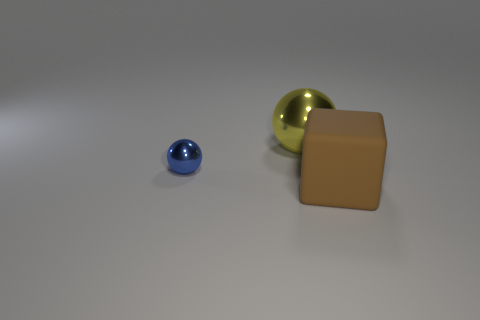Add 3 yellow spheres. How many objects exist? 6 Add 1 big brown matte things. How many big brown matte things exist? 2 Subtract 1 yellow balls. How many objects are left? 2 Subtract all spheres. How many objects are left? 1 Subtract all brown matte things. Subtract all yellow shiny balls. How many objects are left? 1 Add 1 metallic balls. How many metallic balls are left? 3 